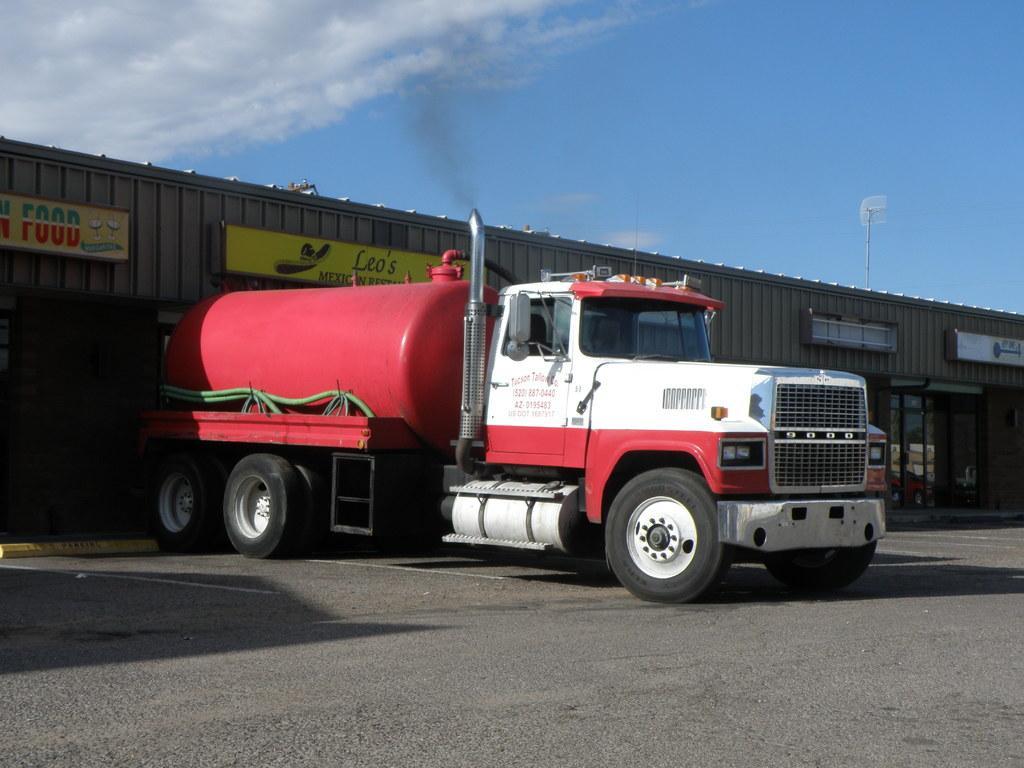In one or two sentences, can you explain what this image depicts? In this picture we can see a liquid tanker, in the background there is a building, we can see hoardings on the left side, on the right side we can see glass door, there is the sky and clouds at the top of the picture. 